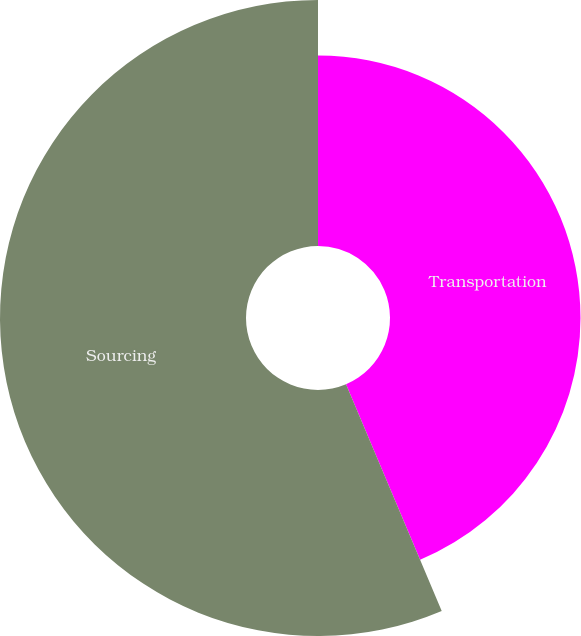Convert chart to OTSL. <chart><loc_0><loc_0><loc_500><loc_500><pie_chart><fcel>Transportation<fcel>Sourcing<nl><fcel>43.64%<fcel>56.36%<nl></chart> 